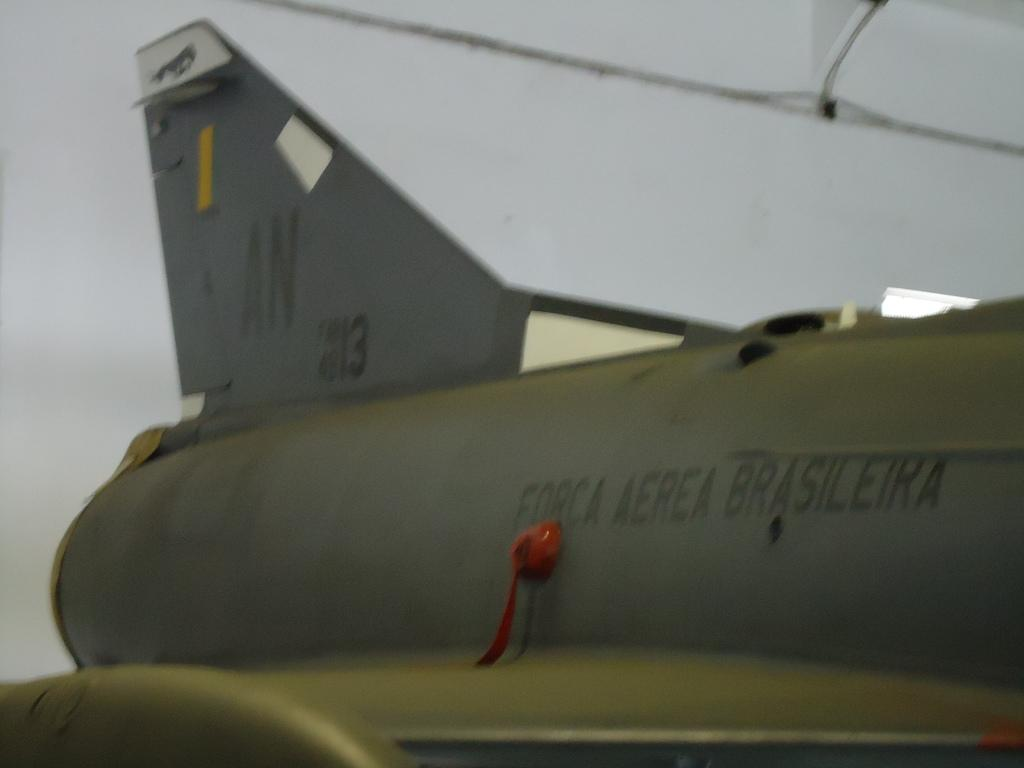<image>
Present a compact description of the photo's key features. A green military airplane with Forca Aerea Brasileira on the side. 